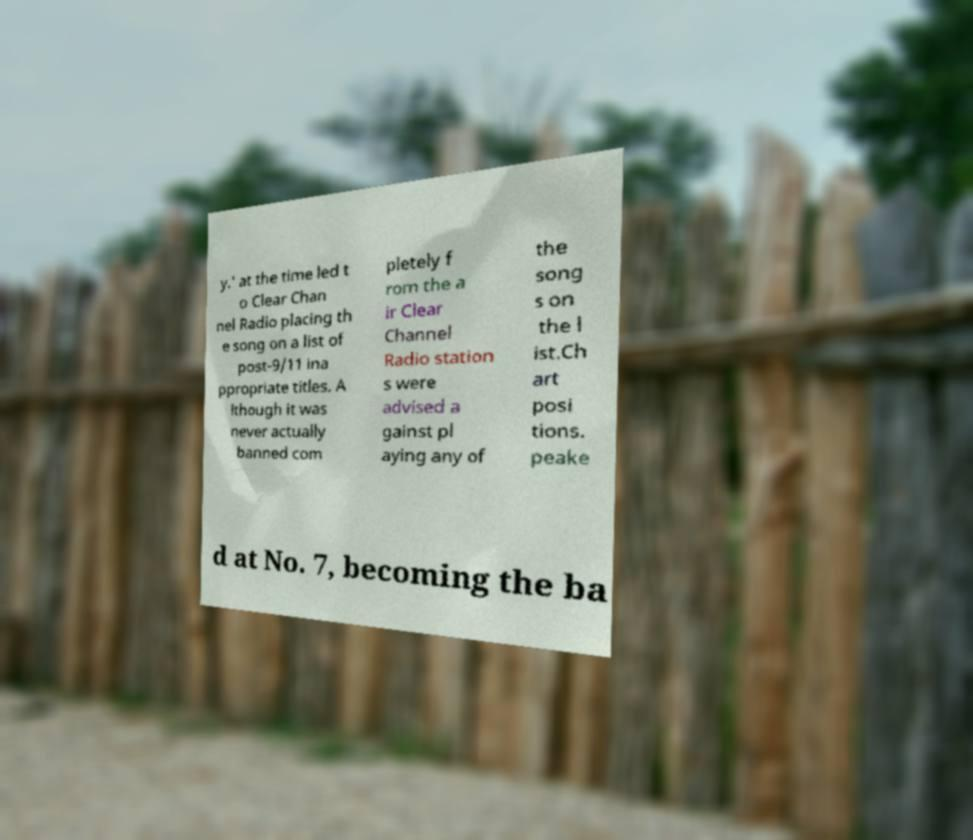There's text embedded in this image that I need extracted. Can you transcribe it verbatim? y.' at the time led t o Clear Chan nel Radio placing th e song on a list of post-9/11 ina ppropriate titles. A lthough it was never actually banned com pletely f rom the a ir Clear Channel Radio station s were advised a gainst pl aying any of the song s on the l ist.Ch art posi tions. peake d at No. 7, becoming the ba 